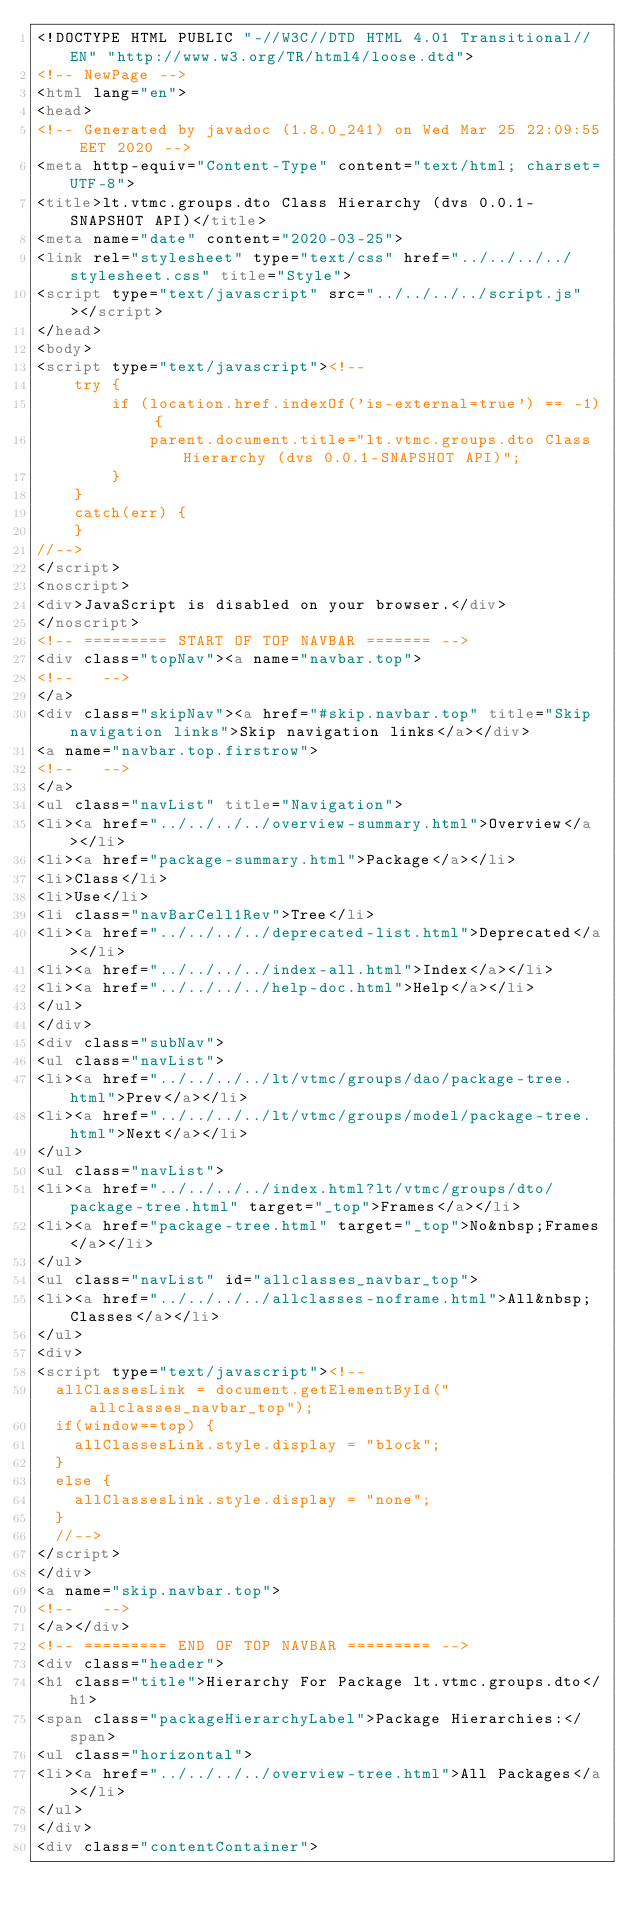<code> <loc_0><loc_0><loc_500><loc_500><_HTML_><!DOCTYPE HTML PUBLIC "-//W3C//DTD HTML 4.01 Transitional//EN" "http://www.w3.org/TR/html4/loose.dtd">
<!-- NewPage -->
<html lang="en">
<head>
<!-- Generated by javadoc (1.8.0_241) on Wed Mar 25 22:09:55 EET 2020 -->
<meta http-equiv="Content-Type" content="text/html; charset=UTF-8">
<title>lt.vtmc.groups.dto Class Hierarchy (dvs 0.0.1-SNAPSHOT API)</title>
<meta name="date" content="2020-03-25">
<link rel="stylesheet" type="text/css" href="../../../../stylesheet.css" title="Style">
<script type="text/javascript" src="../../../../script.js"></script>
</head>
<body>
<script type="text/javascript"><!--
    try {
        if (location.href.indexOf('is-external=true') == -1) {
            parent.document.title="lt.vtmc.groups.dto Class Hierarchy (dvs 0.0.1-SNAPSHOT API)";
        }
    }
    catch(err) {
    }
//-->
</script>
<noscript>
<div>JavaScript is disabled on your browser.</div>
</noscript>
<!-- ========= START OF TOP NAVBAR ======= -->
<div class="topNav"><a name="navbar.top">
<!--   -->
</a>
<div class="skipNav"><a href="#skip.navbar.top" title="Skip navigation links">Skip navigation links</a></div>
<a name="navbar.top.firstrow">
<!--   -->
</a>
<ul class="navList" title="Navigation">
<li><a href="../../../../overview-summary.html">Overview</a></li>
<li><a href="package-summary.html">Package</a></li>
<li>Class</li>
<li>Use</li>
<li class="navBarCell1Rev">Tree</li>
<li><a href="../../../../deprecated-list.html">Deprecated</a></li>
<li><a href="../../../../index-all.html">Index</a></li>
<li><a href="../../../../help-doc.html">Help</a></li>
</ul>
</div>
<div class="subNav">
<ul class="navList">
<li><a href="../../../../lt/vtmc/groups/dao/package-tree.html">Prev</a></li>
<li><a href="../../../../lt/vtmc/groups/model/package-tree.html">Next</a></li>
</ul>
<ul class="navList">
<li><a href="../../../../index.html?lt/vtmc/groups/dto/package-tree.html" target="_top">Frames</a></li>
<li><a href="package-tree.html" target="_top">No&nbsp;Frames</a></li>
</ul>
<ul class="navList" id="allclasses_navbar_top">
<li><a href="../../../../allclasses-noframe.html">All&nbsp;Classes</a></li>
</ul>
<div>
<script type="text/javascript"><!--
  allClassesLink = document.getElementById("allclasses_navbar_top");
  if(window==top) {
    allClassesLink.style.display = "block";
  }
  else {
    allClassesLink.style.display = "none";
  }
  //-->
</script>
</div>
<a name="skip.navbar.top">
<!--   -->
</a></div>
<!-- ========= END OF TOP NAVBAR ========= -->
<div class="header">
<h1 class="title">Hierarchy For Package lt.vtmc.groups.dto</h1>
<span class="packageHierarchyLabel">Package Hierarchies:</span>
<ul class="horizontal">
<li><a href="../../../../overview-tree.html">All Packages</a></li>
</ul>
</div>
<div class="contentContainer"></code> 